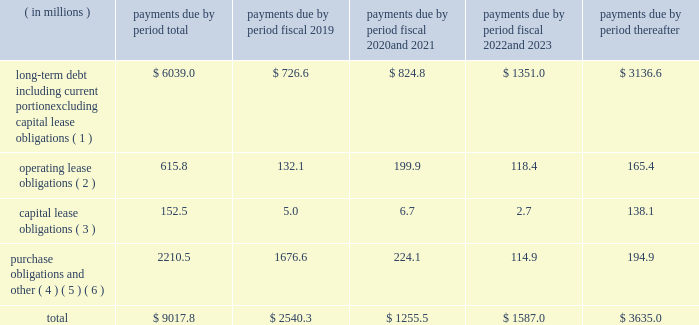Contractual obligations we summarize our enforceable and legally binding contractual obligations at september 30 , 2018 , and the effect these obligations are expected to have on our liquidity and cash flow in future periods in the table .
Certain amounts in this table are based on management fffds estimates and assumptions about these obligations , including their duration , the possibility of renewal , anticipated actions by third parties and other factors , including estimated minimum pension plan contributions and estimated benefit payments related to postretirement obligations , supplemental retirement plans and deferred compensation plans .
Because these estimates and assumptions are subjective , the enforceable and legally binding obligations we actually pay in future periods may vary from those presented in the table. .
( 1 ) includes only principal payments owed on our debt assuming that all of our long-term debt will be held to maturity , excluding scheduled payments .
We have excluded $ 205.2 million of fair value of debt step-up , deferred financing costs and unamortized bond discounts from the table to arrive at actual debt obligations .
See fffdnote 13 .
Debt fffd fffd of the notes to consolidated financial statements for information on the interest rates that apply to our various debt instruments .
( 2 ) see fffdnote 14 .
Operating leases fffd of the notes to consolidated financial statements for additional information .
( 3 ) the fair value step-up of $ 18.5 million is excluded .
See fffdnote 13 .
Debt fffd fffd capital lease and other indebtednesstt fffd of the notes to consolidated financial statements for additional information .
( 4 ) purchase obligations include agreements to purchase goods or services that are enforceable and legally binding and that specify all significant terms , including : fixed or minimum quantities to be purchased ; fixed , minimum or variable price provision ; and the approximate timing of the transaction .
Purchase obligations exclude agreements that are cancelable without penalty .
( 5 ) we have included in the table future estimated minimum pension plan contributions and estimated benefit payments related to postretirement obligations , supplemental retirement plans and deferred compensation plans .
Our estimates are based on factors , such as discount rates and expected returns on plan assets .
Future contributions are subject to changes in our underfunded status based on factors such as investment performance , discount rates , returns on plan assets and changes in legislation .
It is possible that our assumptions may change , actual market performance may vary or we may decide to contribute different amounts .
We have excluded $ 247.8 million of multiemployer pension plan withdrawal liabilities recorded as of september 30 , 2018 due to lack of definite payout terms for certain of the obligations .
See fffdnote 4 .
Retirement plans fffd multiemployer plans fffd of the notes to consolidated financial statements for additional information .
( 6 ) we have not included the following items in the table : fffd an item labeled fffdother long-term liabilities fffd reflected on our consolidated balance sheet because these liabilities do not have a definite pay-out scheme .
Fffd $ 158.4 million from the line item fffdpurchase obligations and other fffd for certain provisions of the financial accounting standards board fffds ( fffdfasb fffd ) accounting standards codification ( fffdasc fffd ) 740 , fffdincome taxes fffd associated with liabilities for uncertain tax positions due to the uncertainty as to the amount and timing of payment , if any .
In addition to the enforceable and legally binding obligations presented in the table above , we have other obligations for goods and services and raw materials entered into in the normal course of business .
These contracts , however , are subject to change based on our business decisions .
Expenditures for environmental compliance see item 1 .
Fffdbusiness fffd fffd governmental regulation fffd environmental and other matters fffd , fffdbusiness fffd fffd governmental regulation fffd cercla and other remediation costs fffd , and fffd fffdbusiness fffd fffd governmental regulation fffd climate change fffd for a discussion of our expenditures for environmental compliance. .
What would the purchase obligations and other be for payments before the period be if they included the multiemployer pension plan? 
Rationale: in line 19 , it says that they did not include the pension plan . to find out what the cost would be if they included the pension plan one needs to add 247.8 ( given in line 19 ) and 2210.5 ( given in the table ) which will give you $ 2458.3 million
Computations: (247.8 + 2210.5)
Answer: 2458.3. 